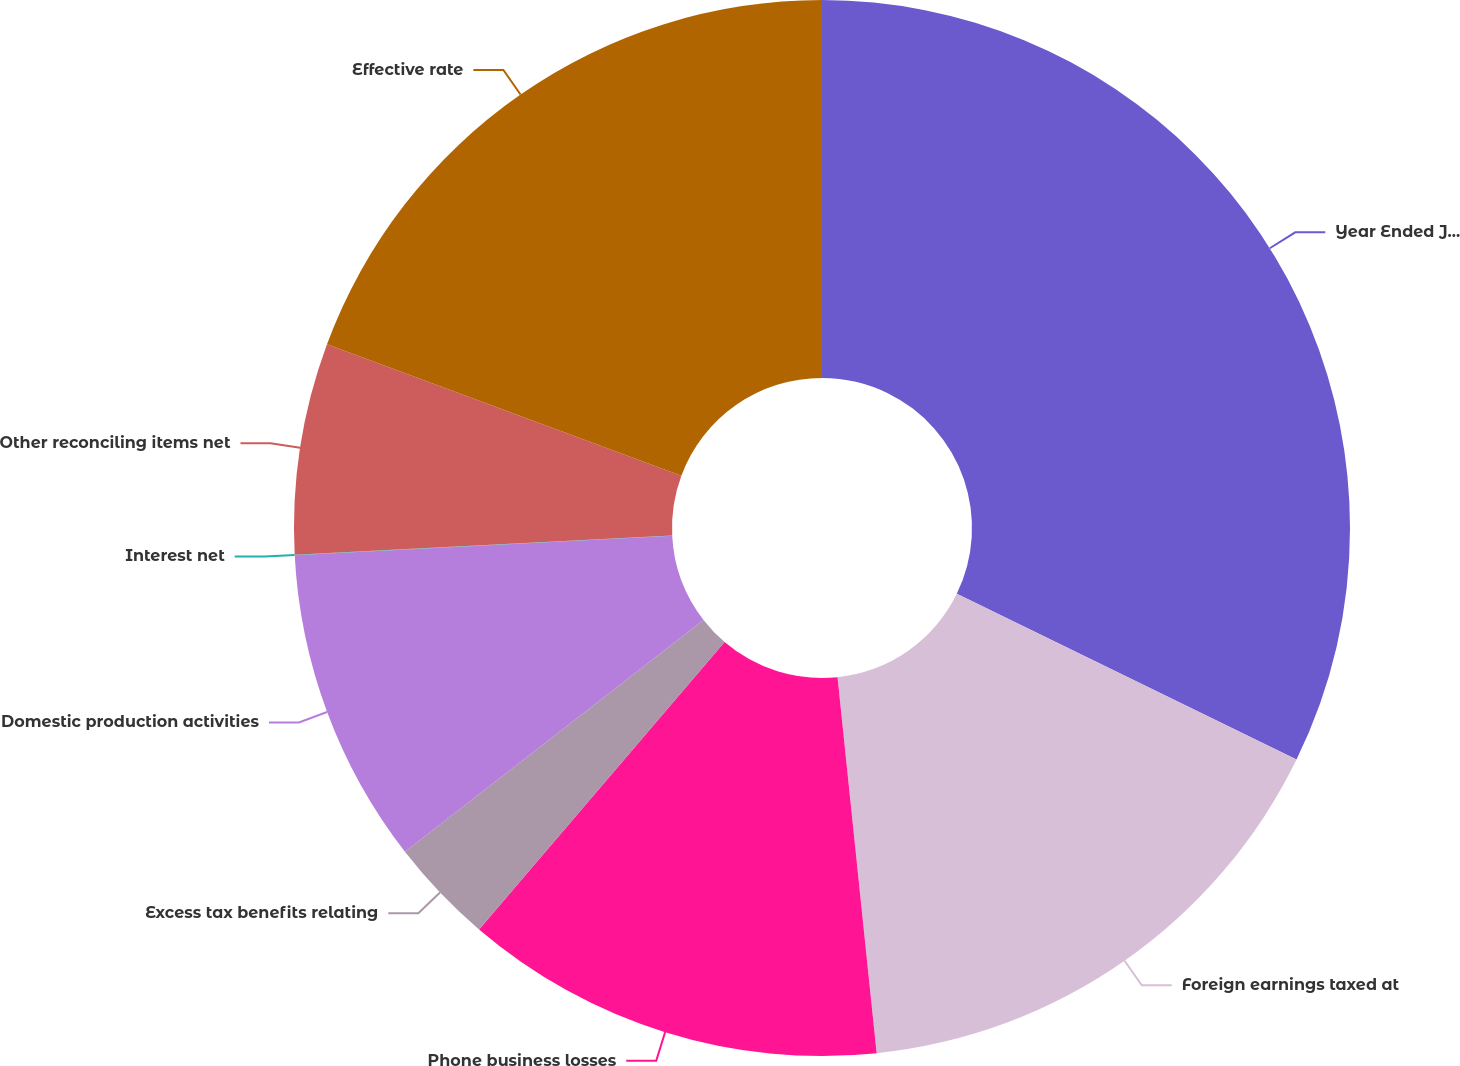<chart> <loc_0><loc_0><loc_500><loc_500><pie_chart><fcel>Year Ended June 30<fcel>Foreign earnings taxed at<fcel>Phone business losses<fcel>Excess tax benefits relating<fcel>Domestic production activities<fcel>Interest net<fcel>Other reconciling items net<fcel>Effective rate<nl><fcel>32.22%<fcel>16.12%<fcel>12.9%<fcel>3.24%<fcel>9.68%<fcel>0.02%<fcel>6.46%<fcel>19.34%<nl></chart> 